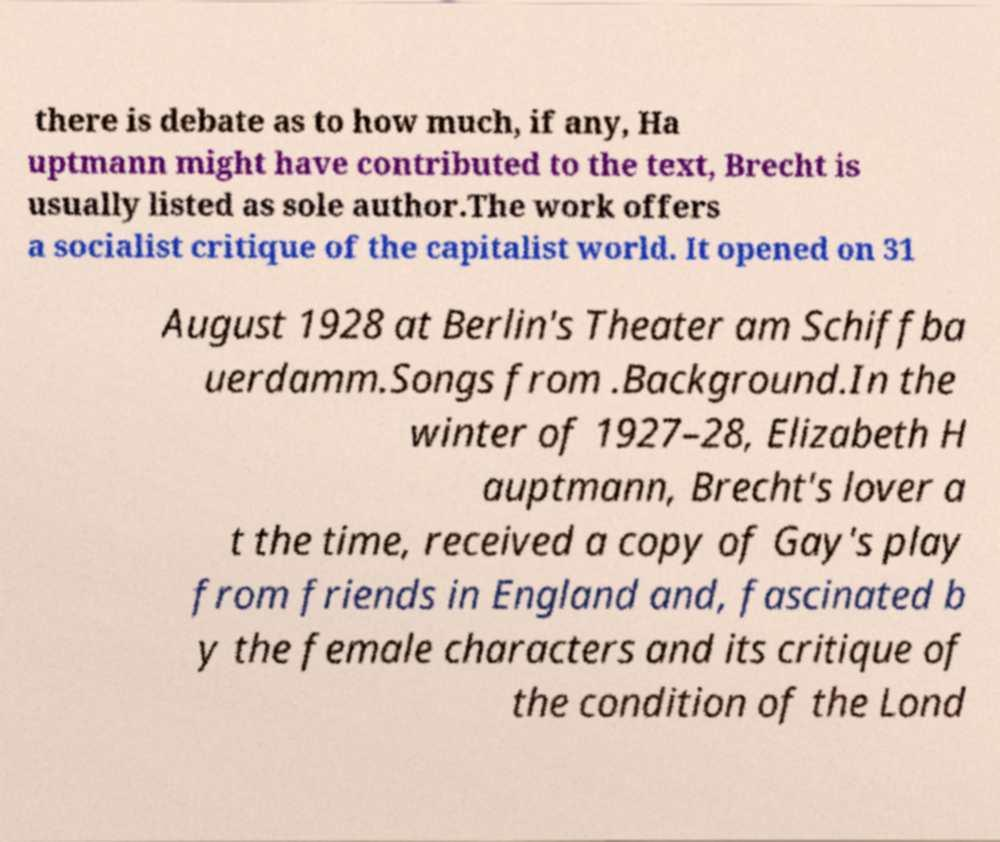There's text embedded in this image that I need extracted. Can you transcribe it verbatim? there is debate as to how much, if any, Ha uptmann might have contributed to the text, Brecht is usually listed as sole author.The work offers a socialist critique of the capitalist world. It opened on 31 August 1928 at Berlin's Theater am Schiffba uerdamm.Songs from .Background.In the winter of 1927–28, Elizabeth H auptmann, Brecht's lover a t the time, received a copy of Gay's play from friends in England and, fascinated b y the female characters and its critique of the condition of the Lond 